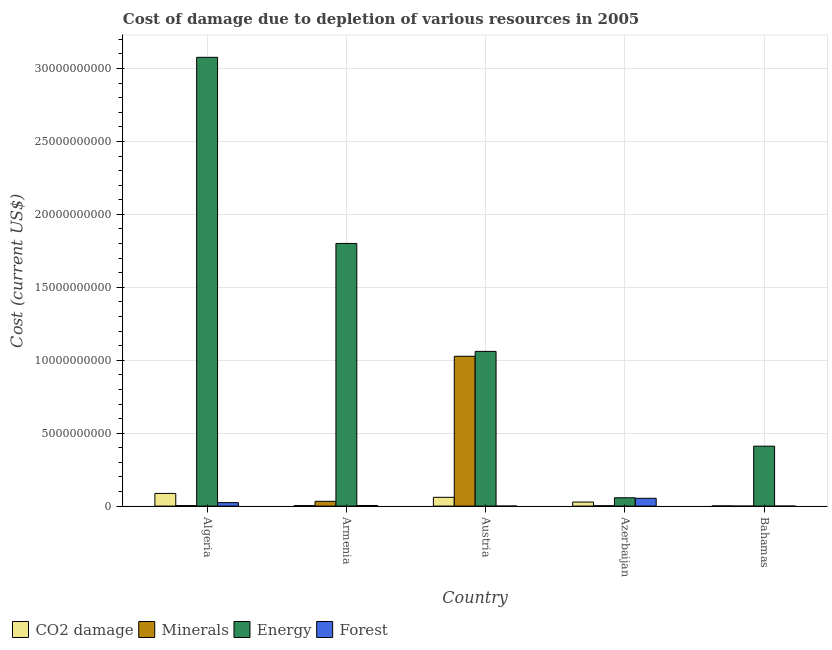What is the label of the 3rd group of bars from the left?
Give a very brief answer. Austria. What is the cost of damage due to depletion of coal in Algeria?
Make the answer very short. 8.68e+08. Across all countries, what is the maximum cost of damage due to depletion of forests?
Offer a very short reply. 5.36e+08. Across all countries, what is the minimum cost of damage due to depletion of energy?
Ensure brevity in your answer.  5.71e+08. In which country was the cost of damage due to depletion of coal maximum?
Give a very brief answer. Algeria. What is the total cost of damage due to depletion of coal in the graph?
Your response must be concise. 1.80e+09. What is the difference between the cost of damage due to depletion of coal in Algeria and that in Armenia?
Make the answer very short. 8.33e+08. What is the difference between the cost of damage due to depletion of forests in Algeria and the cost of damage due to depletion of coal in Austria?
Your answer should be very brief. -3.65e+08. What is the average cost of damage due to depletion of coal per country?
Your answer should be very brief. 3.59e+08. What is the difference between the cost of damage due to depletion of coal and cost of damage due to depletion of minerals in Azerbaijan?
Keep it short and to the point. 2.54e+08. In how many countries, is the cost of damage due to depletion of energy greater than 13000000000 US$?
Your answer should be compact. 2. What is the ratio of the cost of damage due to depletion of energy in Armenia to that in Austria?
Offer a terse response. 1.7. Is the cost of damage due to depletion of forests in Algeria less than that in Austria?
Your answer should be compact. No. What is the difference between the highest and the second highest cost of damage due to depletion of minerals?
Provide a succinct answer. 9.94e+09. What is the difference between the highest and the lowest cost of damage due to depletion of forests?
Keep it short and to the point. 5.36e+08. In how many countries, is the cost of damage due to depletion of forests greater than the average cost of damage due to depletion of forests taken over all countries?
Offer a terse response. 2. Is the sum of the cost of damage due to depletion of coal in Algeria and Armenia greater than the maximum cost of damage due to depletion of forests across all countries?
Ensure brevity in your answer.  Yes. Is it the case that in every country, the sum of the cost of damage due to depletion of minerals and cost of damage due to depletion of energy is greater than the sum of cost of damage due to depletion of forests and cost of damage due to depletion of coal?
Your response must be concise. No. What does the 4th bar from the left in Austria represents?
Offer a terse response. Forest. What does the 2nd bar from the right in Algeria represents?
Ensure brevity in your answer.  Energy. Is it the case that in every country, the sum of the cost of damage due to depletion of coal and cost of damage due to depletion of minerals is greater than the cost of damage due to depletion of energy?
Your answer should be very brief. No. Does the graph contain any zero values?
Make the answer very short. No. How are the legend labels stacked?
Provide a succinct answer. Horizontal. What is the title of the graph?
Provide a succinct answer. Cost of damage due to depletion of various resources in 2005 . What is the label or title of the X-axis?
Provide a short and direct response. Country. What is the label or title of the Y-axis?
Make the answer very short. Cost (current US$). What is the Cost (current US$) in CO2 damage in Algeria?
Your answer should be very brief. 8.68e+08. What is the Cost (current US$) of Minerals in Algeria?
Give a very brief answer. 3.52e+07. What is the Cost (current US$) in Energy in Algeria?
Make the answer very short. 3.08e+1. What is the Cost (current US$) of Forest in Algeria?
Your response must be concise. 2.37e+08. What is the Cost (current US$) in CO2 damage in Armenia?
Give a very brief answer. 3.53e+07. What is the Cost (current US$) of Minerals in Armenia?
Provide a succinct answer. 3.29e+08. What is the Cost (current US$) in Energy in Armenia?
Keep it short and to the point. 1.80e+1. What is the Cost (current US$) in Forest in Armenia?
Provide a short and direct response. 4.18e+07. What is the Cost (current US$) of CO2 damage in Austria?
Your response must be concise. 6.02e+08. What is the Cost (current US$) of Minerals in Austria?
Make the answer very short. 1.03e+1. What is the Cost (current US$) of Energy in Austria?
Your answer should be compact. 1.06e+1. What is the Cost (current US$) in Forest in Austria?
Provide a succinct answer. 1.37e+05. What is the Cost (current US$) in CO2 damage in Azerbaijan?
Ensure brevity in your answer.  2.78e+08. What is the Cost (current US$) in Minerals in Azerbaijan?
Your answer should be compact. 2.43e+07. What is the Cost (current US$) in Energy in Azerbaijan?
Your response must be concise. 5.71e+08. What is the Cost (current US$) in Forest in Azerbaijan?
Keep it short and to the point. 5.36e+08. What is the Cost (current US$) in CO2 damage in Bahamas?
Keep it short and to the point. 1.30e+07. What is the Cost (current US$) in Minerals in Bahamas?
Ensure brevity in your answer.  1.14e+05. What is the Cost (current US$) of Energy in Bahamas?
Provide a succinct answer. 4.11e+09. What is the Cost (current US$) of Forest in Bahamas?
Give a very brief answer. 5.98e+05. Across all countries, what is the maximum Cost (current US$) in CO2 damage?
Keep it short and to the point. 8.68e+08. Across all countries, what is the maximum Cost (current US$) in Minerals?
Your answer should be compact. 1.03e+1. Across all countries, what is the maximum Cost (current US$) in Energy?
Your answer should be very brief. 3.08e+1. Across all countries, what is the maximum Cost (current US$) of Forest?
Give a very brief answer. 5.36e+08. Across all countries, what is the minimum Cost (current US$) in CO2 damage?
Provide a short and direct response. 1.30e+07. Across all countries, what is the minimum Cost (current US$) in Minerals?
Give a very brief answer. 1.14e+05. Across all countries, what is the minimum Cost (current US$) of Energy?
Offer a very short reply. 5.71e+08. Across all countries, what is the minimum Cost (current US$) in Forest?
Your response must be concise. 1.37e+05. What is the total Cost (current US$) in CO2 damage in the graph?
Keep it short and to the point. 1.80e+09. What is the total Cost (current US$) of Minerals in the graph?
Your answer should be very brief. 1.07e+1. What is the total Cost (current US$) of Energy in the graph?
Offer a terse response. 6.41e+1. What is the total Cost (current US$) in Forest in the graph?
Offer a very short reply. 8.16e+08. What is the difference between the Cost (current US$) of CO2 damage in Algeria and that in Armenia?
Offer a terse response. 8.33e+08. What is the difference between the Cost (current US$) of Minerals in Algeria and that in Armenia?
Your response must be concise. -2.94e+08. What is the difference between the Cost (current US$) of Energy in Algeria and that in Armenia?
Offer a terse response. 1.28e+1. What is the difference between the Cost (current US$) in Forest in Algeria and that in Armenia?
Keep it short and to the point. 1.95e+08. What is the difference between the Cost (current US$) in CO2 damage in Algeria and that in Austria?
Make the answer very short. 2.66e+08. What is the difference between the Cost (current US$) of Minerals in Algeria and that in Austria?
Provide a short and direct response. -1.02e+1. What is the difference between the Cost (current US$) in Energy in Algeria and that in Austria?
Your answer should be compact. 2.02e+1. What is the difference between the Cost (current US$) of Forest in Algeria and that in Austria?
Give a very brief answer. 2.37e+08. What is the difference between the Cost (current US$) in CO2 damage in Algeria and that in Azerbaijan?
Your answer should be compact. 5.90e+08. What is the difference between the Cost (current US$) of Minerals in Algeria and that in Azerbaijan?
Provide a succinct answer. 1.08e+07. What is the difference between the Cost (current US$) in Energy in Algeria and that in Azerbaijan?
Your answer should be very brief. 3.02e+1. What is the difference between the Cost (current US$) in Forest in Algeria and that in Azerbaijan?
Provide a succinct answer. -2.99e+08. What is the difference between the Cost (current US$) in CO2 damage in Algeria and that in Bahamas?
Your answer should be very brief. 8.55e+08. What is the difference between the Cost (current US$) of Minerals in Algeria and that in Bahamas?
Make the answer very short. 3.51e+07. What is the difference between the Cost (current US$) of Energy in Algeria and that in Bahamas?
Provide a succinct answer. 2.67e+1. What is the difference between the Cost (current US$) of Forest in Algeria and that in Bahamas?
Offer a terse response. 2.37e+08. What is the difference between the Cost (current US$) in CO2 damage in Armenia and that in Austria?
Your answer should be compact. -5.67e+08. What is the difference between the Cost (current US$) in Minerals in Armenia and that in Austria?
Your answer should be compact. -9.94e+09. What is the difference between the Cost (current US$) in Energy in Armenia and that in Austria?
Provide a succinct answer. 7.40e+09. What is the difference between the Cost (current US$) in Forest in Armenia and that in Austria?
Your response must be concise. 4.17e+07. What is the difference between the Cost (current US$) of CO2 damage in Armenia and that in Azerbaijan?
Your answer should be compact. -2.43e+08. What is the difference between the Cost (current US$) of Minerals in Armenia and that in Azerbaijan?
Give a very brief answer. 3.04e+08. What is the difference between the Cost (current US$) of Energy in Armenia and that in Azerbaijan?
Offer a very short reply. 1.74e+1. What is the difference between the Cost (current US$) of Forest in Armenia and that in Azerbaijan?
Offer a terse response. -4.94e+08. What is the difference between the Cost (current US$) of CO2 damage in Armenia and that in Bahamas?
Your answer should be compact. 2.23e+07. What is the difference between the Cost (current US$) of Minerals in Armenia and that in Bahamas?
Make the answer very short. 3.29e+08. What is the difference between the Cost (current US$) in Energy in Armenia and that in Bahamas?
Ensure brevity in your answer.  1.39e+1. What is the difference between the Cost (current US$) in Forest in Armenia and that in Bahamas?
Your answer should be compact. 4.13e+07. What is the difference between the Cost (current US$) in CO2 damage in Austria and that in Azerbaijan?
Offer a terse response. 3.24e+08. What is the difference between the Cost (current US$) in Minerals in Austria and that in Azerbaijan?
Your answer should be very brief. 1.02e+1. What is the difference between the Cost (current US$) of Energy in Austria and that in Azerbaijan?
Keep it short and to the point. 1.00e+1. What is the difference between the Cost (current US$) of Forest in Austria and that in Azerbaijan?
Ensure brevity in your answer.  -5.36e+08. What is the difference between the Cost (current US$) in CO2 damage in Austria and that in Bahamas?
Your response must be concise. 5.89e+08. What is the difference between the Cost (current US$) of Minerals in Austria and that in Bahamas?
Keep it short and to the point. 1.03e+1. What is the difference between the Cost (current US$) of Energy in Austria and that in Bahamas?
Provide a succinct answer. 6.50e+09. What is the difference between the Cost (current US$) in Forest in Austria and that in Bahamas?
Provide a short and direct response. -4.60e+05. What is the difference between the Cost (current US$) of CO2 damage in Azerbaijan and that in Bahamas?
Offer a very short reply. 2.65e+08. What is the difference between the Cost (current US$) in Minerals in Azerbaijan and that in Bahamas?
Your answer should be very brief. 2.42e+07. What is the difference between the Cost (current US$) in Energy in Azerbaijan and that in Bahamas?
Your response must be concise. -3.54e+09. What is the difference between the Cost (current US$) of Forest in Azerbaijan and that in Bahamas?
Ensure brevity in your answer.  5.35e+08. What is the difference between the Cost (current US$) in CO2 damage in Algeria and the Cost (current US$) in Minerals in Armenia?
Ensure brevity in your answer.  5.39e+08. What is the difference between the Cost (current US$) in CO2 damage in Algeria and the Cost (current US$) in Energy in Armenia?
Provide a short and direct response. -1.71e+1. What is the difference between the Cost (current US$) in CO2 damage in Algeria and the Cost (current US$) in Forest in Armenia?
Keep it short and to the point. 8.26e+08. What is the difference between the Cost (current US$) in Minerals in Algeria and the Cost (current US$) in Energy in Armenia?
Offer a very short reply. -1.80e+1. What is the difference between the Cost (current US$) in Minerals in Algeria and the Cost (current US$) in Forest in Armenia?
Provide a succinct answer. -6.68e+06. What is the difference between the Cost (current US$) in Energy in Algeria and the Cost (current US$) in Forest in Armenia?
Ensure brevity in your answer.  3.07e+1. What is the difference between the Cost (current US$) in CO2 damage in Algeria and the Cost (current US$) in Minerals in Austria?
Keep it short and to the point. -9.40e+09. What is the difference between the Cost (current US$) in CO2 damage in Algeria and the Cost (current US$) in Energy in Austria?
Provide a short and direct response. -9.74e+09. What is the difference between the Cost (current US$) in CO2 damage in Algeria and the Cost (current US$) in Forest in Austria?
Your answer should be very brief. 8.68e+08. What is the difference between the Cost (current US$) in Minerals in Algeria and the Cost (current US$) in Energy in Austria?
Give a very brief answer. -1.06e+1. What is the difference between the Cost (current US$) in Minerals in Algeria and the Cost (current US$) in Forest in Austria?
Your answer should be very brief. 3.50e+07. What is the difference between the Cost (current US$) of Energy in Algeria and the Cost (current US$) of Forest in Austria?
Your answer should be very brief. 3.08e+1. What is the difference between the Cost (current US$) of CO2 damage in Algeria and the Cost (current US$) of Minerals in Azerbaijan?
Give a very brief answer. 8.44e+08. What is the difference between the Cost (current US$) in CO2 damage in Algeria and the Cost (current US$) in Energy in Azerbaijan?
Give a very brief answer. 2.97e+08. What is the difference between the Cost (current US$) in CO2 damage in Algeria and the Cost (current US$) in Forest in Azerbaijan?
Provide a succinct answer. 3.32e+08. What is the difference between the Cost (current US$) in Minerals in Algeria and the Cost (current US$) in Energy in Azerbaijan?
Your answer should be very brief. -5.36e+08. What is the difference between the Cost (current US$) in Minerals in Algeria and the Cost (current US$) in Forest in Azerbaijan?
Make the answer very short. -5.01e+08. What is the difference between the Cost (current US$) of Energy in Algeria and the Cost (current US$) of Forest in Azerbaijan?
Ensure brevity in your answer.  3.02e+1. What is the difference between the Cost (current US$) in CO2 damage in Algeria and the Cost (current US$) in Minerals in Bahamas?
Ensure brevity in your answer.  8.68e+08. What is the difference between the Cost (current US$) of CO2 damage in Algeria and the Cost (current US$) of Energy in Bahamas?
Your answer should be very brief. -3.24e+09. What is the difference between the Cost (current US$) of CO2 damage in Algeria and the Cost (current US$) of Forest in Bahamas?
Offer a terse response. 8.68e+08. What is the difference between the Cost (current US$) of Minerals in Algeria and the Cost (current US$) of Energy in Bahamas?
Ensure brevity in your answer.  -4.07e+09. What is the difference between the Cost (current US$) of Minerals in Algeria and the Cost (current US$) of Forest in Bahamas?
Keep it short and to the point. 3.46e+07. What is the difference between the Cost (current US$) of Energy in Algeria and the Cost (current US$) of Forest in Bahamas?
Your answer should be very brief. 3.08e+1. What is the difference between the Cost (current US$) of CO2 damage in Armenia and the Cost (current US$) of Minerals in Austria?
Provide a short and direct response. -1.02e+1. What is the difference between the Cost (current US$) in CO2 damage in Armenia and the Cost (current US$) in Energy in Austria?
Your response must be concise. -1.06e+1. What is the difference between the Cost (current US$) in CO2 damage in Armenia and the Cost (current US$) in Forest in Austria?
Offer a terse response. 3.51e+07. What is the difference between the Cost (current US$) in Minerals in Armenia and the Cost (current US$) in Energy in Austria?
Provide a short and direct response. -1.03e+1. What is the difference between the Cost (current US$) of Minerals in Armenia and the Cost (current US$) of Forest in Austria?
Offer a very short reply. 3.29e+08. What is the difference between the Cost (current US$) in Energy in Armenia and the Cost (current US$) in Forest in Austria?
Provide a short and direct response. 1.80e+1. What is the difference between the Cost (current US$) of CO2 damage in Armenia and the Cost (current US$) of Minerals in Azerbaijan?
Your answer should be very brief. 1.09e+07. What is the difference between the Cost (current US$) of CO2 damage in Armenia and the Cost (current US$) of Energy in Azerbaijan?
Keep it short and to the point. -5.36e+08. What is the difference between the Cost (current US$) of CO2 damage in Armenia and the Cost (current US$) of Forest in Azerbaijan?
Offer a very short reply. -5.01e+08. What is the difference between the Cost (current US$) of Minerals in Armenia and the Cost (current US$) of Energy in Azerbaijan?
Offer a very short reply. -2.43e+08. What is the difference between the Cost (current US$) of Minerals in Armenia and the Cost (current US$) of Forest in Azerbaijan?
Make the answer very short. -2.07e+08. What is the difference between the Cost (current US$) in Energy in Armenia and the Cost (current US$) in Forest in Azerbaijan?
Your answer should be compact. 1.75e+1. What is the difference between the Cost (current US$) of CO2 damage in Armenia and the Cost (current US$) of Minerals in Bahamas?
Your answer should be very brief. 3.52e+07. What is the difference between the Cost (current US$) in CO2 damage in Armenia and the Cost (current US$) in Energy in Bahamas?
Your response must be concise. -4.07e+09. What is the difference between the Cost (current US$) in CO2 damage in Armenia and the Cost (current US$) in Forest in Bahamas?
Your answer should be compact. 3.47e+07. What is the difference between the Cost (current US$) in Minerals in Armenia and the Cost (current US$) in Energy in Bahamas?
Ensure brevity in your answer.  -3.78e+09. What is the difference between the Cost (current US$) of Minerals in Armenia and the Cost (current US$) of Forest in Bahamas?
Your answer should be very brief. 3.28e+08. What is the difference between the Cost (current US$) of Energy in Armenia and the Cost (current US$) of Forest in Bahamas?
Keep it short and to the point. 1.80e+1. What is the difference between the Cost (current US$) of CO2 damage in Austria and the Cost (current US$) of Minerals in Azerbaijan?
Provide a succinct answer. 5.78e+08. What is the difference between the Cost (current US$) of CO2 damage in Austria and the Cost (current US$) of Energy in Azerbaijan?
Provide a short and direct response. 3.07e+07. What is the difference between the Cost (current US$) of CO2 damage in Austria and the Cost (current US$) of Forest in Azerbaijan?
Offer a very short reply. 6.62e+07. What is the difference between the Cost (current US$) in Minerals in Austria and the Cost (current US$) in Energy in Azerbaijan?
Your answer should be very brief. 9.70e+09. What is the difference between the Cost (current US$) of Minerals in Austria and the Cost (current US$) of Forest in Azerbaijan?
Offer a very short reply. 9.74e+09. What is the difference between the Cost (current US$) in Energy in Austria and the Cost (current US$) in Forest in Azerbaijan?
Your response must be concise. 1.01e+1. What is the difference between the Cost (current US$) in CO2 damage in Austria and the Cost (current US$) in Minerals in Bahamas?
Offer a very short reply. 6.02e+08. What is the difference between the Cost (current US$) of CO2 damage in Austria and the Cost (current US$) of Energy in Bahamas?
Provide a succinct answer. -3.51e+09. What is the difference between the Cost (current US$) in CO2 damage in Austria and the Cost (current US$) in Forest in Bahamas?
Your answer should be very brief. 6.01e+08. What is the difference between the Cost (current US$) in Minerals in Austria and the Cost (current US$) in Energy in Bahamas?
Your response must be concise. 6.16e+09. What is the difference between the Cost (current US$) in Minerals in Austria and the Cost (current US$) in Forest in Bahamas?
Provide a succinct answer. 1.03e+1. What is the difference between the Cost (current US$) in Energy in Austria and the Cost (current US$) in Forest in Bahamas?
Ensure brevity in your answer.  1.06e+1. What is the difference between the Cost (current US$) of CO2 damage in Azerbaijan and the Cost (current US$) of Minerals in Bahamas?
Offer a very short reply. 2.78e+08. What is the difference between the Cost (current US$) of CO2 damage in Azerbaijan and the Cost (current US$) of Energy in Bahamas?
Your answer should be very brief. -3.83e+09. What is the difference between the Cost (current US$) in CO2 damage in Azerbaijan and the Cost (current US$) in Forest in Bahamas?
Keep it short and to the point. 2.78e+08. What is the difference between the Cost (current US$) of Minerals in Azerbaijan and the Cost (current US$) of Energy in Bahamas?
Your response must be concise. -4.09e+09. What is the difference between the Cost (current US$) of Minerals in Azerbaijan and the Cost (current US$) of Forest in Bahamas?
Offer a terse response. 2.37e+07. What is the difference between the Cost (current US$) of Energy in Azerbaijan and the Cost (current US$) of Forest in Bahamas?
Offer a very short reply. 5.71e+08. What is the average Cost (current US$) of CO2 damage per country?
Make the answer very short. 3.59e+08. What is the average Cost (current US$) of Minerals per country?
Provide a short and direct response. 2.13e+09. What is the average Cost (current US$) of Energy per country?
Ensure brevity in your answer.  1.28e+1. What is the average Cost (current US$) in Forest per country?
Offer a very short reply. 1.63e+08. What is the difference between the Cost (current US$) of CO2 damage and Cost (current US$) of Minerals in Algeria?
Give a very brief answer. 8.33e+08. What is the difference between the Cost (current US$) of CO2 damage and Cost (current US$) of Energy in Algeria?
Make the answer very short. -2.99e+1. What is the difference between the Cost (current US$) in CO2 damage and Cost (current US$) in Forest in Algeria?
Your answer should be compact. 6.31e+08. What is the difference between the Cost (current US$) in Minerals and Cost (current US$) in Energy in Algeria?
Give a very brief answer. -3.07e+1. What is the difference between the Cost (current US$) of Minerals and Cost (current US$) of Forest in Algeria?
Your answer should be very brief. -2.02e+08. What is the difference between the Cost (current US$) of Energy and Cost (current US$) of Forest in Algeria?
Ensure brevity in your answer.  3.05e+1. What is the difference between the Cost (current US$) in CO2 damage and Cost (current US$) in Minerals in Armenia?
Offer a very short reply. -2.94e+08. What is the difference between the Cost (current US$) of CO2 damage and Cost (current US$) of Energy in Armenia?
Keep it short and to the point. -1.80e+1. What is the difference between the Cost (current US$) of CO2 damage and Cost (current US$) of Forest in Armenia?
Provide a succinct answer. -6.57e+06. What is the difference between the Cost (current US$) in Minerals and Cost (current US$) in Energy in Armenia?
Make the answer very short. -1.77e+1. What is the difference between the Cost (current US$) of Minerals and Cost (current US$) of Forest in Armenia?
Make the answer very short. 2.87e+08. What is the difference between the Cost (current US$) of Energy and Cost (current US$) of Forest in Armenia?
Offer a terse response. 1.80e+1. What is the difference between the Cost (current US$) of CO2 damage and Cost (current US$) of Minerals in Austria?
Provide a short and direct response. -9.67e+09. What is the difference between the Cost (current US$) of CO2 damage and Cost (current US$) of Energy in Austria?
Make the answer very short. -1.00e+1. What is the difference between the Cost (current US$) of CO2 damage and Cost (current US$) of Forest in Austria?
Offer a very short reply. 6.02e+08. What is the difference between the Cost (current US$) in Minerals and Cost (current US$) in Energy in Austria?
Give a very brief answer. -3.36e+08. What is the difference between the Cost (current US$) in Minerals and Cost (current US$) in Forest in Austria?
Ensure brevity in your answer.  1.03e+1. What is the difference between the Cost (current US$) in Energy and Cost (current US$) in Forest in Austria?
Your answer should be very brief. 1.06e+1. What is the difference between the Cost (current US$) of CO2 damage and Cost (current US$) of Minerals in Azerbaijan?
Make the answer very short. 2.54e+08. What is the difference between the Cost (current US$) in CO2 damage and Cost (current US$) in Energy in Azerbaijan?
Offer a very short reply. -2.93e+08. What is the difference between the Cost (current US$) in CO2 damage and Cost (current US$) in Forest in Azerbaijan?
Your response must be concise. -2.58e+08. What is the difference between the Cost (current US$) of Minerals and Cost (current US$) of Energy in Azerbaijan?
Ensure brevity in your answer.  -5.47e+08. What is the difference between the Cost (current US$) in Minerals and Cost (current US$) in Forest in Azerbaijan?
Provide a succinct answer. -5.11e+08. What is the difference between the Cost (current US$) of Energy and Cost (current US$) of Forest in Azerbaijan?
Your response must be concise. 3.56e+07. What is the difference between the Cost (current US$) of CO2 damage and Cost (current US$) of Minerals in Bahamas?
Ensure brevity in your answer.  1.28e+07. What is the difference between the Cost (current US$) of CO2 damage and Cost (current US$) of Energy in Bahamas?
Make the answer very short. -4.10e+09. What is the difference between the Cost (current US$) in CO2 damage and Cost (current US$) in Forest in Bahamas?
Ensure brevity in your answer.  1.24e+07. What is the difference between the Cost (current US$) in Minerals and Cost (current US$) in Energy in Bahamas?
Your answer should be very brief. -4.11e+09. What is the difference between the Cost (current US$) of Minerals and Cost (current US$) of Forest in Bahamas?
Offer a very short reply. -4.84e+05. What is the difference between the Cost (current US$) of Energy and Cost (current US$) of Forest in Bahamas?
Offer a terse response. 4.11e+09. What is the ratio of the Cost (current US$) in CO2 damage in Algeria to that in Armenia?
Your response must be concise. 24.61. What is the ratio of the Cost (current US$) in Minerals in Algeria to that in Armenia?
Your answer should be compact. 0.11. What is the ratio of the Cost (current US$) of Energy in Algeria to that in Armenia?
Ensure brevity in your answer.  1.71. What is the ratio of the Cost (current US$) in Forest in Algeria to that in Armenia?
Provide a short and direct response. 5.67. What is the ratio of the Cost (current US$) of CO2 damage in Algeria to that in Austria?
Keep it short and to the point. 1.44. What is the ratio of the Cost (current US$) of Minerals in Algeria to that in Austria?
Provide a succinct answer. 0. What is the ratio of the Cost (current US$) of Energy in Algeria to that in Austria?
Keep it short and to the point. 2.9. What is the ratio of the Cost (current US$) of Forest in Algeria to that in Austria?
Your answer should be compact. 1728.92. What is the ratio of the Cost (current US$) in CO2 damage in Algeria to that in Azerbaijan?
Your response must be concise. 3.12. What is the ratio of the Cost (current US$) in Minerals in Algeria to that in Azerbaijan?
Offer a very short reply. 1.44. What is the ratio of the Cost (current US$) of Energy in Algeria to that in Azerbaijan?
Keep it short and to the point. 53.85. What is the ratio of the Cost (current US$) in Forest in Algeria to that in Azerbaijan?
Make the answer very short. 0.44. What is the ratio of the Cost (current US$) of CO2 damage in Algeria to that in Bahamas?
Make the answer very short. 67. What is the ratio of the Cost (current US$) of Minerals in Algeria to that in Bahamas?
Offer a terse response. 309.71. What is the ratio of the Cost (current US$) in Energy in Algeria to that in Bahamas?
Ensure brevity in your answer.  7.49. What is the ratio of the Cost (current US$) in Forest in Algeria to that in Bahamas?
Offer a terse response. 397.04. What is the ratio of the Cost (current US$) in CO2 damage in Armenia to that in Austria?
Your answer should be compact. 0.06. What is the ratio of the Cost (current US$) in Minerals in Armenia to that in Austria?
Provide a short and direct response. 0.03. What is the ratio of the Cost (current US$) in Energy in Armenia to that in Austria?
Ensure brevity in your answer.  1.7. What is the ratio of the Cost (current US$) in Forest in Armenia to that in Austria?
Offer a very short reply. 304.97. What is the ratio of the Cost (current US$) in CO2 damage in Armenia to that in Azerbaijan?
Provide a short and direct response. 0.13. What is the ratio of the Cost (current US$) in Minerals in Armenia to that in Azerbaijan?
Offer a very short reply. 13.51. What is the ratio of the Cost (current US$) of Energy in Armenia to that in Azerbaijan?
Offer a terse response. 31.52. What is the ratio of the Cost (current US$) of Forest in Armenia to that in Azerbaijan?
Make the answer very short. 0.08. What is the ratio of the Cost (current US$) in CO2 damage in Armenia to that in Bahamas?
Your answer should be compact. 2.72. What is the ratio of the Cost (current US$) of Minerals in Armenia to that in Bahamas?
Your answer should be very brief. 2896.16. What is the ratio of the Cost (current US$) in Energy in Armenia to that in Bahamas?
Your answer should be very brief. 4.38. What is the ratio of the Cost (current US$) of Forest in Armenia to that in Bahamas?
Offer a very short reply. 70.03. What is the ratio of the Cost (current US$) in CO2 damage in Austria to that in Azerbaijan?
Make the answer very short. 2.16. What is the ratio of the Cost (current US$) in Minerals in Austria to that in Azerbaijan?
Your answer should be compact. 421.93. What is the ratio of the Cost (current US$) in Energy in Austria to that in Azerbaijan?
Your answer should be compact. 18.57. What is the ratio of the Cost (current US$) of CO2 damage in Austria to that in Bahamas?
Offer a very short reply. 46.46. What is the ratio of the Cost (current US$) of Minerals in Austria to that in Bahamas?
Give a very brief answer. 9.05e+04. What is the ratio of the Cost (current US$) of Energy in Austria to that in Bahamas?
Your response must be concise. 2.58. What is the ratio of the Cost (current US$) in Forest in Austria to that in Bahamas?
Provide a succinct answer. 0.23. What is the ratio of the Cost (current US$) of CO2 damage in Azerbaijan to that in Bahamas?
Provide a short and direct response. 21.48. What is the ratio of the Cost (current US$) of Minerals in Azerbaijan to that in Bahamas?
Offer a very short reply. 214.43. What is the ratio of the Cost (current US$) in Energy in Azerbaijan to that in Bahamas?
Make the answer very short. 0.14. What is the ratio of the Cost (current US$) of Forest in Azerbaijan to that in Bahamas?
Your answer should be compact. 896.72. What is the difference between the highest and the second highest Cost (current US$) in CO2 damage?
Offer a very short reply. 2.66e+08. What is the difference between the highest and the second highest Cost (current US$) of Minerals?
Make the answer very short. 9.94e+09. What is the difference between the highest and the second highest Cost (current US$) in Energy?
Make the answer very short. 1.28e+1. What is the difference between the highest and the second highest Cost (current US$) in Forest?
Give a very brief answer. 2.99e+08. What is the difference between the highest and the lowest Cost (current US$) of CO2 damage?
Offer a terse response. 8.55e+08. What is the difference between the highest and the lowest Cost (current US$) in Minerals?
Offer a very short reply. 1.03e+1. What is the difference between the highest and the lowest Cost (current US$) in Energy?
Offer a very short reply. 3.02e+1. What is the difference between the highest and the lowest Cost (current US$) in Forest?
Make the answer very short. 5.36e+08. 